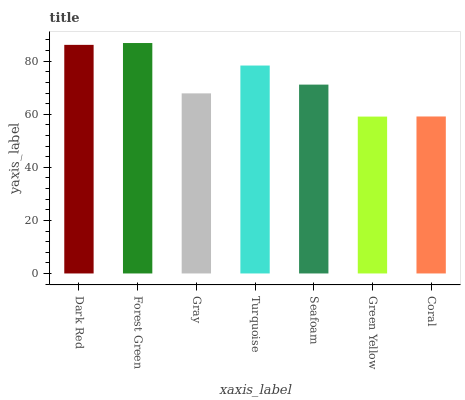Is Green Yellow the minimum?
Answer yes or no. Yes. Is Forest Green the maximum?
Answer yes or no. Yes. Is Gray the minimum?
Answer yes or no. No. Is Gray the maximum?
Answer yes or no. No. Is Forest Green greater than Gray?
Answer yes or no. Yes. Is Gray less than Forest Green?
Answer yes or no. Yes. Is Gray greater than Forest Green?
Answer yes or no. No. Is Forest Green less than Gray?
Answer yes or no. No. Is Seafoam the high median?
Answer yes or no. Yes. Is Seafoam the low median?
Answer yes or no. Yes. Is Forest Green the high median?
Answer yes or no. No. Is Turquoise the low median?
Answer yes or no. No. 